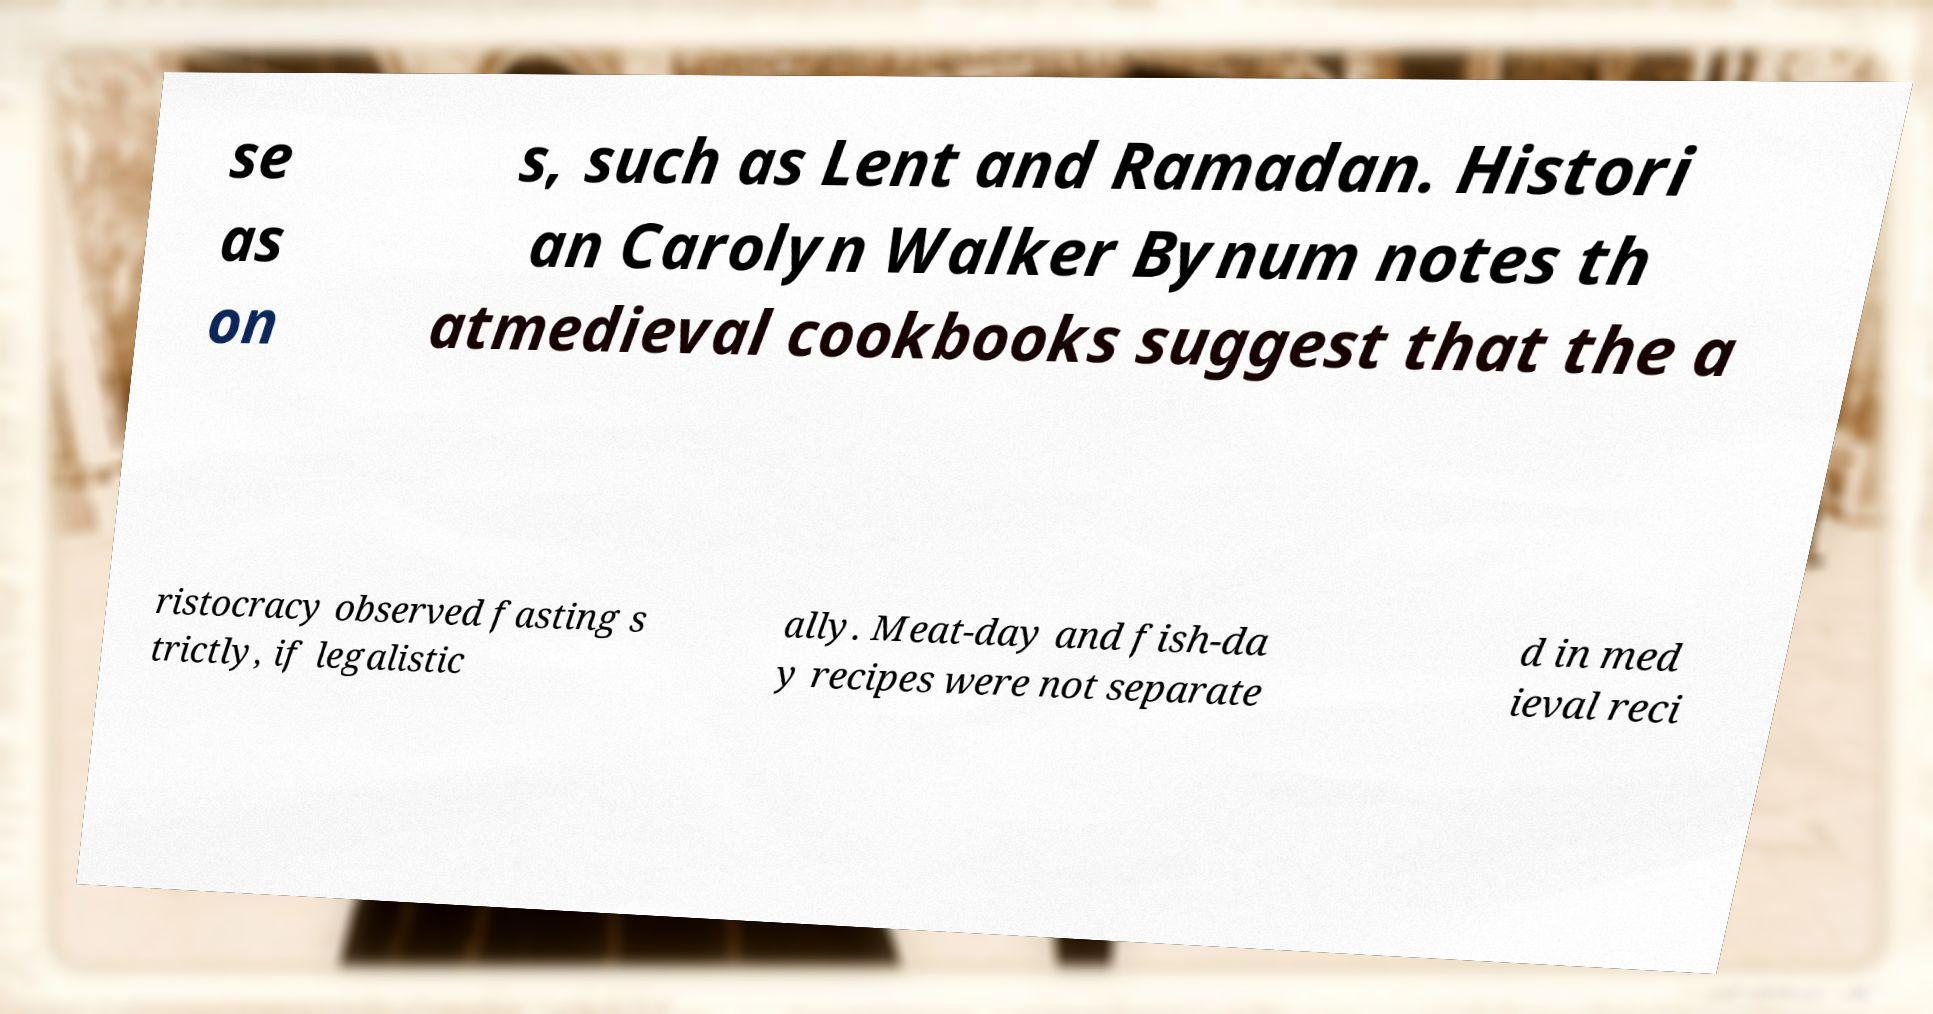Can you accurately transcribe the text from the provided image for me? se as on s, such as Lent and Ramadan. Histori an Carolyn Walker Bynum notes th atmedieval cookbooks suggest that the a ristocracy observed fasting s trictly, if legalistic ally. Meat-day and fish-da y recipes were not separate d in med ieval reci 